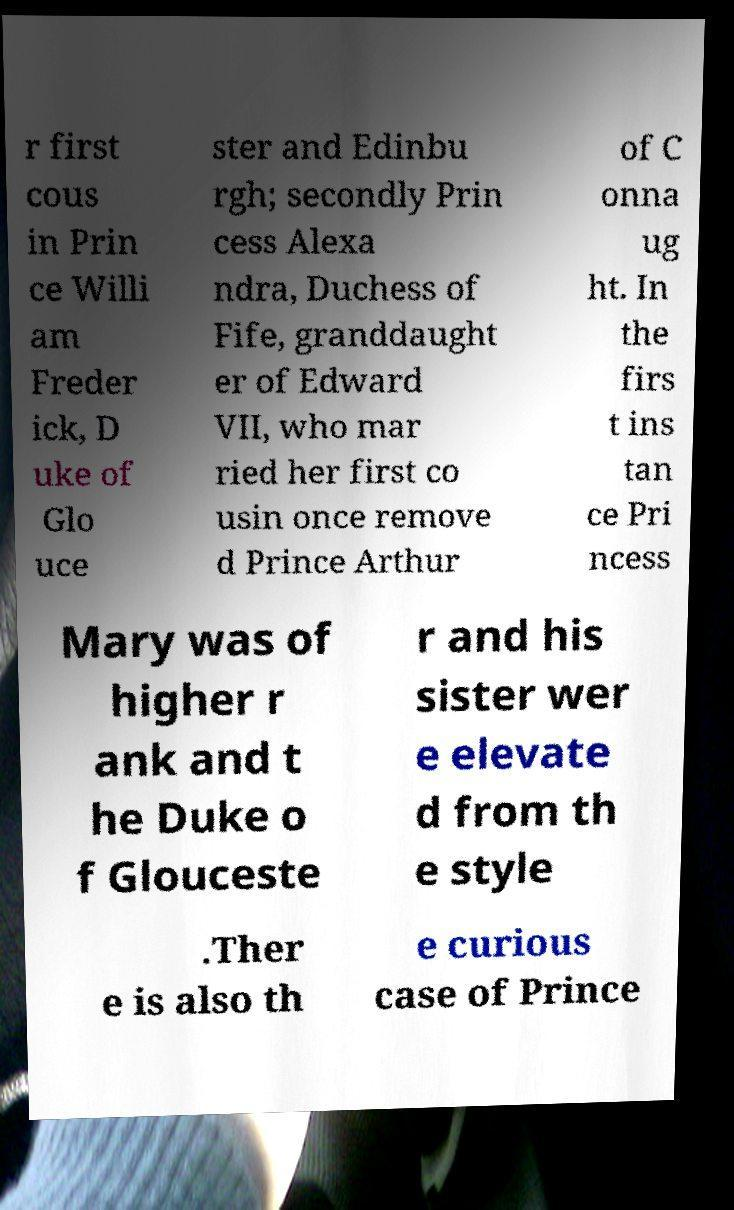I need the written content from this picture converted into text. Can you do that? r first cous in Prin ce Willi am Freder ick, D uke of Glo uce ster and Edinbu rgh; secondly Prin cess Alexa ndra, Duchess of Fife, granddaught er of Edward VII, who mar ried her first co usin once remove d Prince Arthur of C onna ug ht. In the firs t ins tan ce Pri ncess Mary was of higher r ank and t he Duke o f Glouceste r and his sister wer e elevate d from th e style .Ther e is also th e curious case of Prince 